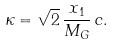Convert formula to latex. <formula><loc_0><loc_0><loc_500><loc_500>\kappa = \sqrt { 2 } \, \frac { x _ { 1 } } { M _ { G } } \, c .</formula> 